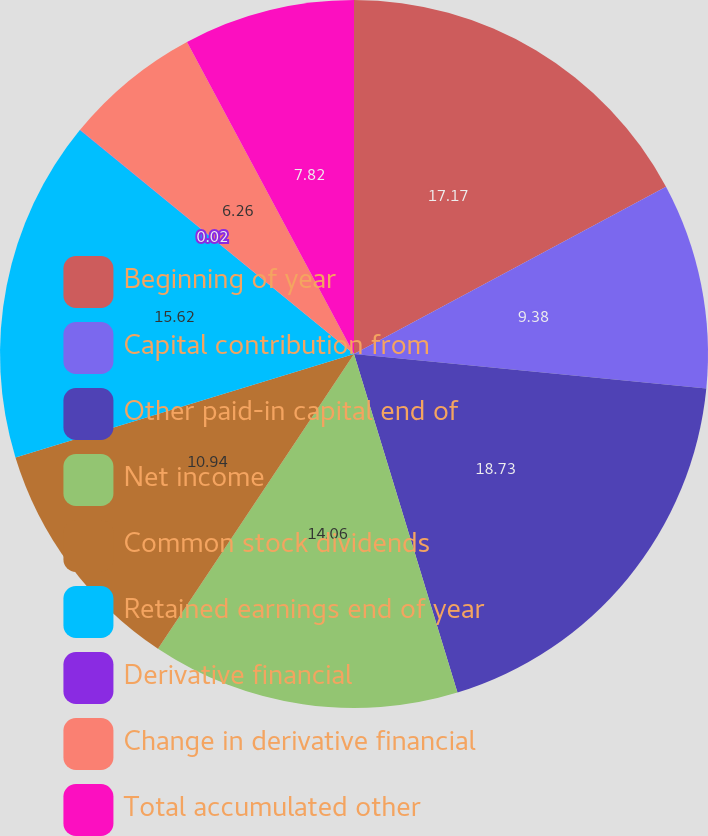Convert chart. <chart><loc_0><loc_0><loc_500><loc_500><pie_chart><fcel>Beginning of year<fcel>Capital contribution from<fcel>Other paid-in capital end of<fcel>Net income<fcel>Common stock dividends<fcel>Retained earnings end of year<fcel>Derivative financial<fcel>Change in derivative financial<fcel>Total accumulated other<nl><fcel>17.17%<fcel>9.38%<fcel>18.73%<fcel>14.06%<fcel>10.94%<fcel>15.62%<fcel>0.02%<fcel>6.26%<fcel>7.82%<nl></chart> 